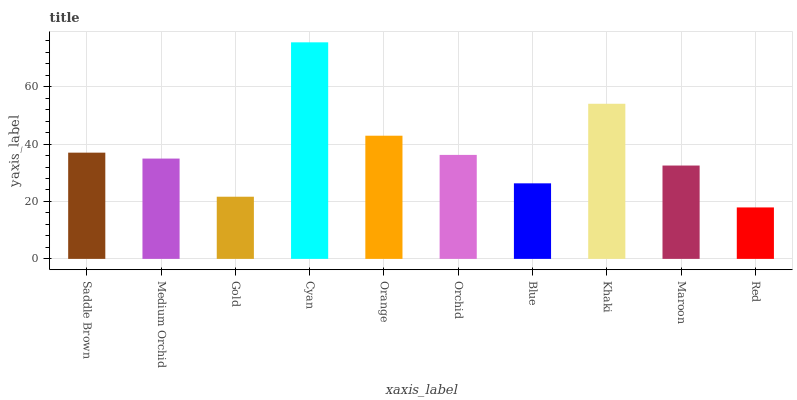Is Medium Orchid the minimum?
Answer yes or no. No. Is Medium Orchid the maximum?
Answer yes or no. No. Is Saddle Brown greater than Medium Orchid?
Answer yes or no. Yes. Is Medium Orchid less than Saddle Brown?
Answer yes or no. Yes. Is Medium Orchid greater than Saddle Brown?
Answer yes or no. No. Is Saddle Brown less than Medium Orchid?
Answer yes or no. No. Is Orchid the high median?
Answer yes or no. Yes. Is Medium Orchid the low median?
Answer yes or no. Yes. Is Maroon the high median?
Answer yes or no. No. Is Khaki the low median?
Answer yes or no. No. 